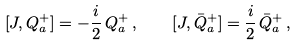<formula> <loc_0><loc_0><loc_500><loc_500>[ J , Q ^ { + } _ { a } ] = - { \frac { i } { 2 } } \, Q ^ { + } _ { a } \, , \quad [ J , \bar { Q } ^ { + } _ { a } ] = { \frac { i } { 2 } } \, \bar { Q } ^ { + } _ { a } \, ,</formula> 